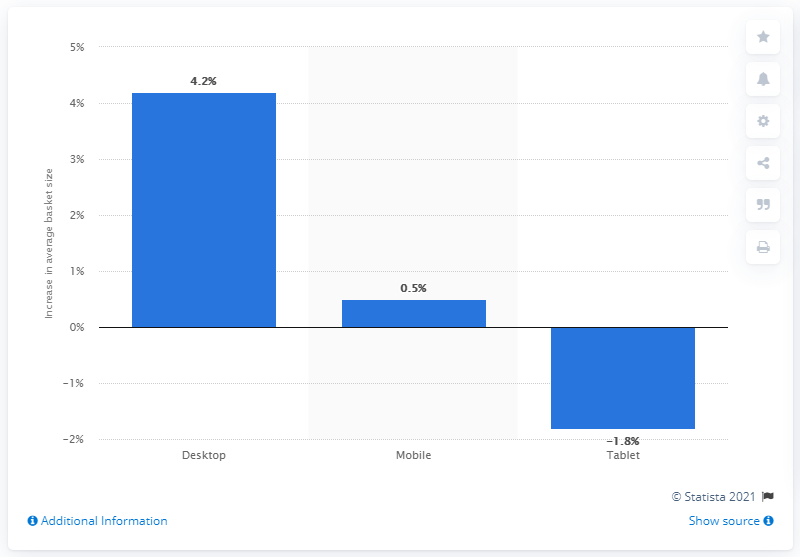What was the increase in desktop computers from 2015 to 2016?
 4.2 